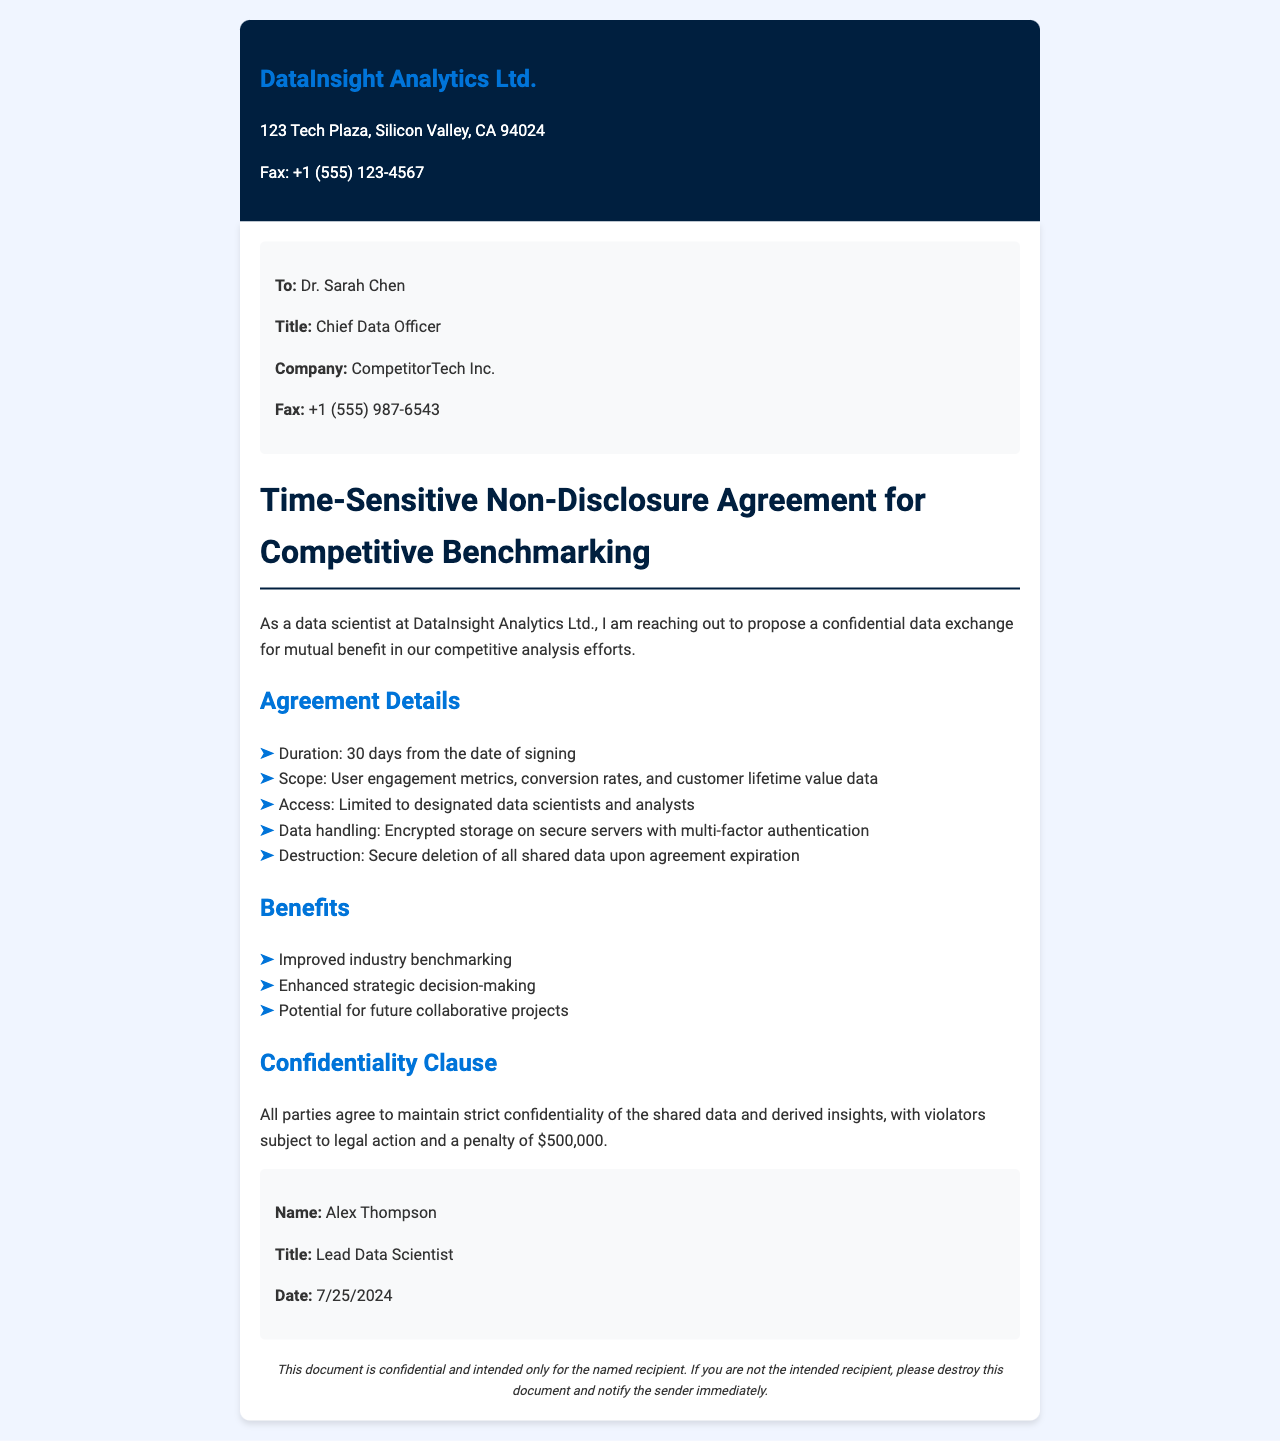What is the company name of the recipient? The recipient of the fax is associated with the company named in the document, which is CompetitorTech Inc.
Answer: CompetitorTech Inc What is the duration of the agreement? The agreement specifies a duration that is clearly mentioned in the document.
Answer: 30 days Who is the sender of the document? The name of the sender is stated in the signature block at the bottom of the document.
Answer: Alex Thompson What type of data is being requested? The document outlines the specific types of data needed for the benchmarking analysis in a list format.
Answer: User engagement metrics, conversion rates, and customer lifetime value data What is the penalty for violating the confidentiality clause? The document specifies a penalty for confidentiality breach that is stated clearly.
Answer: $500,000 What is the title of the recipient? The title of the recipient is mentioned in the section that identifies the recipient's details.
Answer: Chief Data Officer 